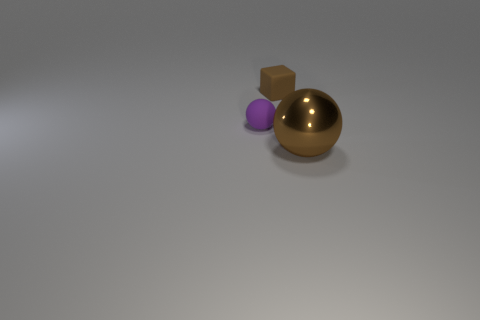Add 3 large yellow blocks. How many objects exist? 6 Subtract all blocks. How many objects are left? 2 Subtract 0 cyan cylinders. How many objects are left? 3 Subtract all large purple rubber balls. Subtract all purple rubber things. How many objects are left? 2 Add 3 brown metal spheres. How many brown metal spheres are left? 4 Add 2 large gray blocks. How many large gray blocks exist? 2 